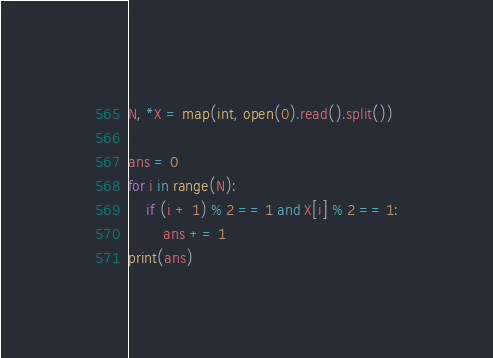<code> <loc_0><loc_0><loc_500><loc_500><_Python_>N, *X = map(int, open(0).read().split())

ans = 0
for i in range(N):
    if (i + 1) % 2 == 1 and X[i] % 2 == 1:
        ans += 1
print(ans)</code> 